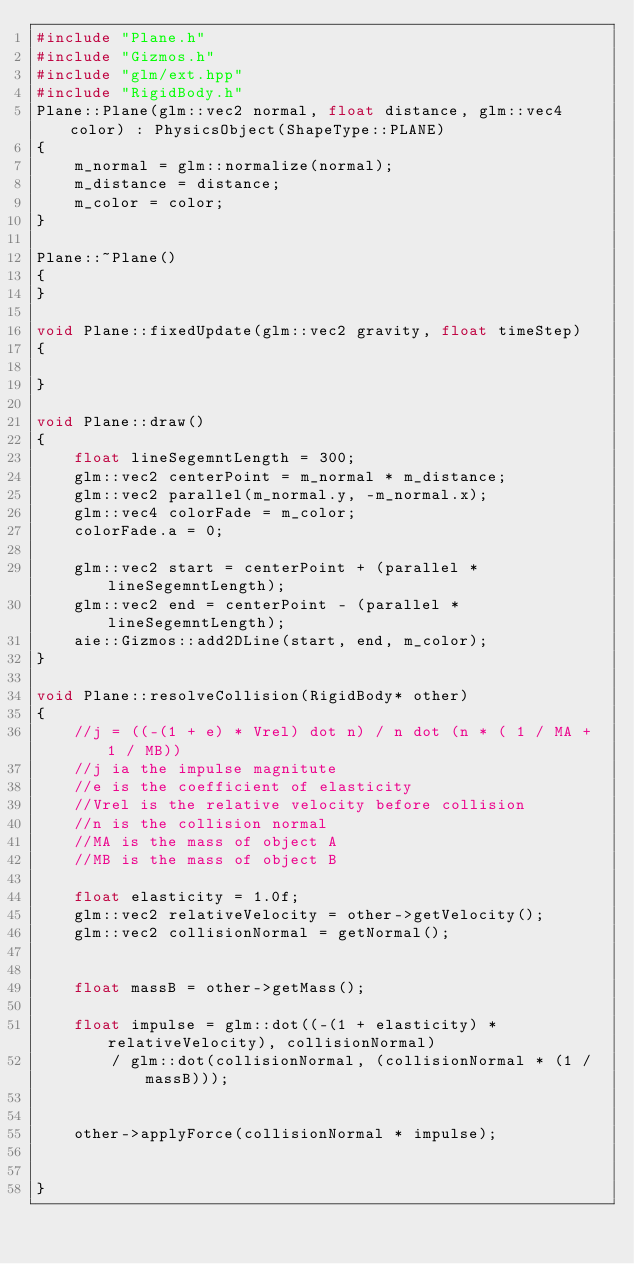Convert code to text. <code><loc_0><loc_0><loc_500><loc_500><_C++_>#include "Plane.h"
#include "Gizmos.h"
#include "glm/ext.hpp"
#include "RigidBody.h"
Plane::Plane(glm::vec2 normal, float distance, glm::vec4 color) : PhysicsObject(ShapeType::PLANE)
{
	m_normal = glm::normalize(normal);
	m_distance = distance;
	m_color = color;
}

Plane::~Plane()
{
}

void Plane::fixedUpdate(glm::vec2 gravity, float timeStep)
{
	
}

void Plane::draw()
{
	float lineSegemntLength = 300;
	glm::vec2 centerPoint = m_normal * m_distance;
	glm::vec2 parallel(m_normal.y, -m_normal.x);
	glm::vec4 colorFade = m_color;
	colorFade.a = 0;

	glm::vec2 start = centerPoint + (parallel * lineSegemntLength);
	glm::vec2 end = centerPoint - (parallel * lineSegemntLength);
	aie::Gizmos::add2DLine(start, end, m_color);
}

void Plane::resolveCollision(RigidBody* other)
{
	//j = ((-(1 + e) * Vrel) dot n) / n dot (n * ( 1 / MA + 1 / MB))
	//j ia the impulse magnitute
	//e is the coefficient of elasticity
	//Vrel is the relative velocity before collision
	//n is the collision normal
	//MA is the mass of object A
	//MB is the mass of object B

	float elasticity = 1.0f;
	glm::vec2 relativeVelocity = other->getVelocity();
	glm::vec2 collisionNormal = getNormal();


	float massB = other->getMass();

	float impulse = glm::dot((-(1 + elasticity) * relativeVelocity), collisionNormal)
		/ glm::dot(collisionNormal, (collisionNormal * (1 / massB)));


	other->applyForce(collisionNormal * impulse);


}
</code> 